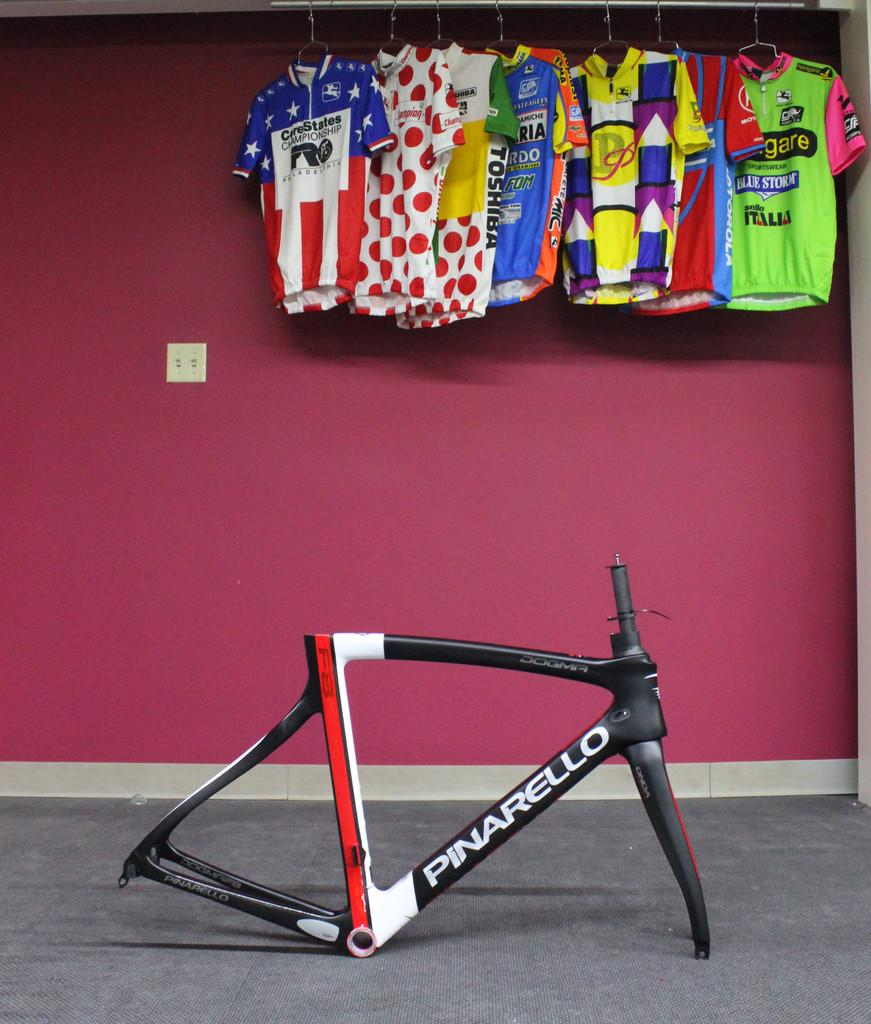<image>
Render a clear and concise summary of the photo. A group of Toshiba shirts in the closet hanging.. 